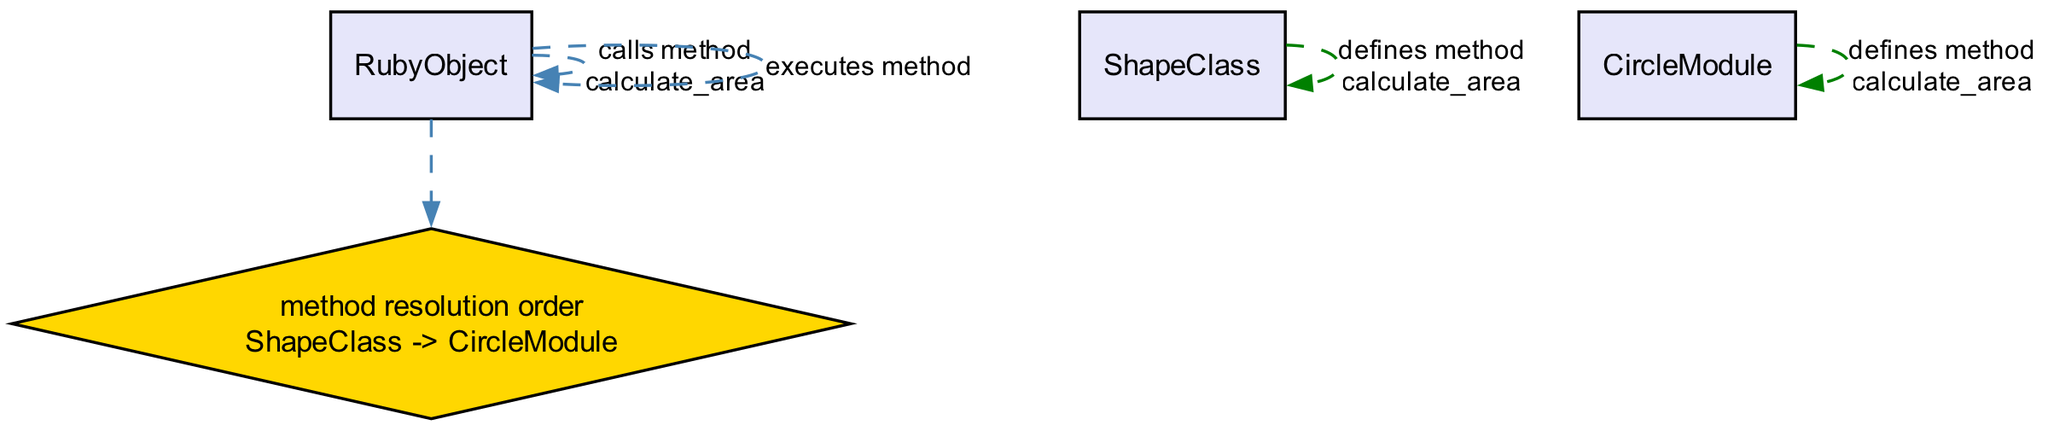What method does the RubyObject call first? The RubyObject initiates the interaction by calling the method named "calculate_area." From the diagram, this action is clearly depicted as the first interaction by the RubyObject.
Answer: calculate_area Which class defines the method calculate_area? The diagram shows that the method "calculate_area" is defined within the ShapeClass. The response indicates that ShapeClass is responsible for this method definition.
Answer: ShapeClass What is the order of method resolution shown in the diagram? The method resolution order (MRO) is specified in the diagram as "ShapeClass -> CircleModule." This specifies the order in which Ruby will look for the method implementation.
Answer: ShapeClass -> CircleModule How many methods are defined in total? There are two methods defined in the diagram: one in ShapeClass and one in CircleModule. Only these two methods are mentioned, regardless of who calls them.
Answer: 2 Which resource is executed for the calculate_area method? According to the diagram, when the RubyObject calls calculate_area and resolving the method, it executes the method from ShapeClass, as indicated in the last action.
Answer: ShapeClass.calculate_area What decision does RubyObject make regarding method resolution? The RubyObject makes a decision based on the method resolution order, which leads to the selection of ShapeClass over CircleModule for executing the method. This decision is explicitly highlighted in the diagram.
Answer: method resolution order What color represents the method definitions in the diagram? The method definitions in the diagram are represented with green edges, indicating that these are responses for method definitions and are not action calls.
Answer: Green Which actor is responsible for calling the method calculate_area? Based on the diagram, the actor responsible for calling the method "calculate_area" is RubyObject, as shown in the first element of the interaction.
Answer: RubyObject 